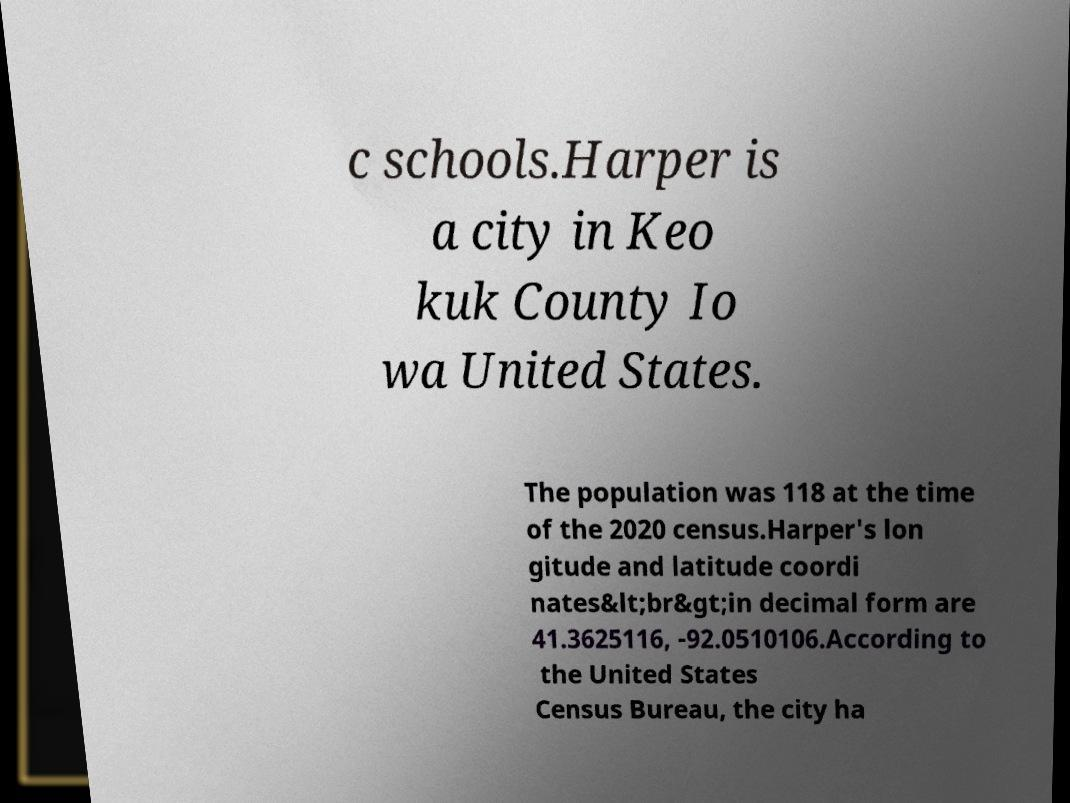Can you read and provide the text displayed in the image?This photo seems to have some interesting text. Can you extract and type it out for me? c schools.Harper is a city in Keo kuk County Io wa United States. The population was 118 at the time of the 2020 census.Harper's lon gitude and latitude coordi nates&lt;br&gt;in decimal form are 41.3625116, -92.0510106.According to the United States Census Bureau, the city ha 